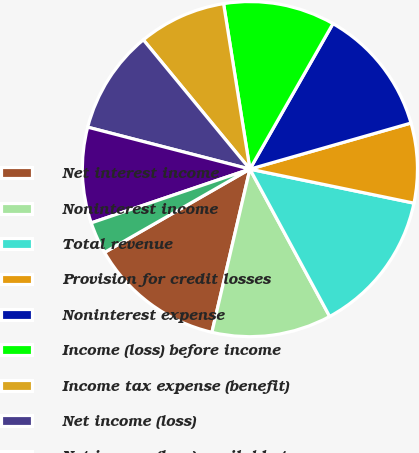<chart> <loc_0><loc_0><loc_500><loc_500><pie_chart><fcel>Net interest income<fcel>Noninterest income<fcel>Total revenue<fcel>Provision for credit losses<fcel>Noninterest expense<fcel>Income (loss) before income<fcel>Income tax expense (benefit)<fcel>Net income (loss)<fcel>Net income (loss) available to<fcel>Net income (loss) per average<nl><fcel>13.08%<fcel>11.54%<fcel>13.85%<fcel>7.69%<fcel>12.31%<fcel>10.77%<fcel>8.46%<fcel>10.0%<fcel>9.23%<fcel>3.08%<nl></chart> 